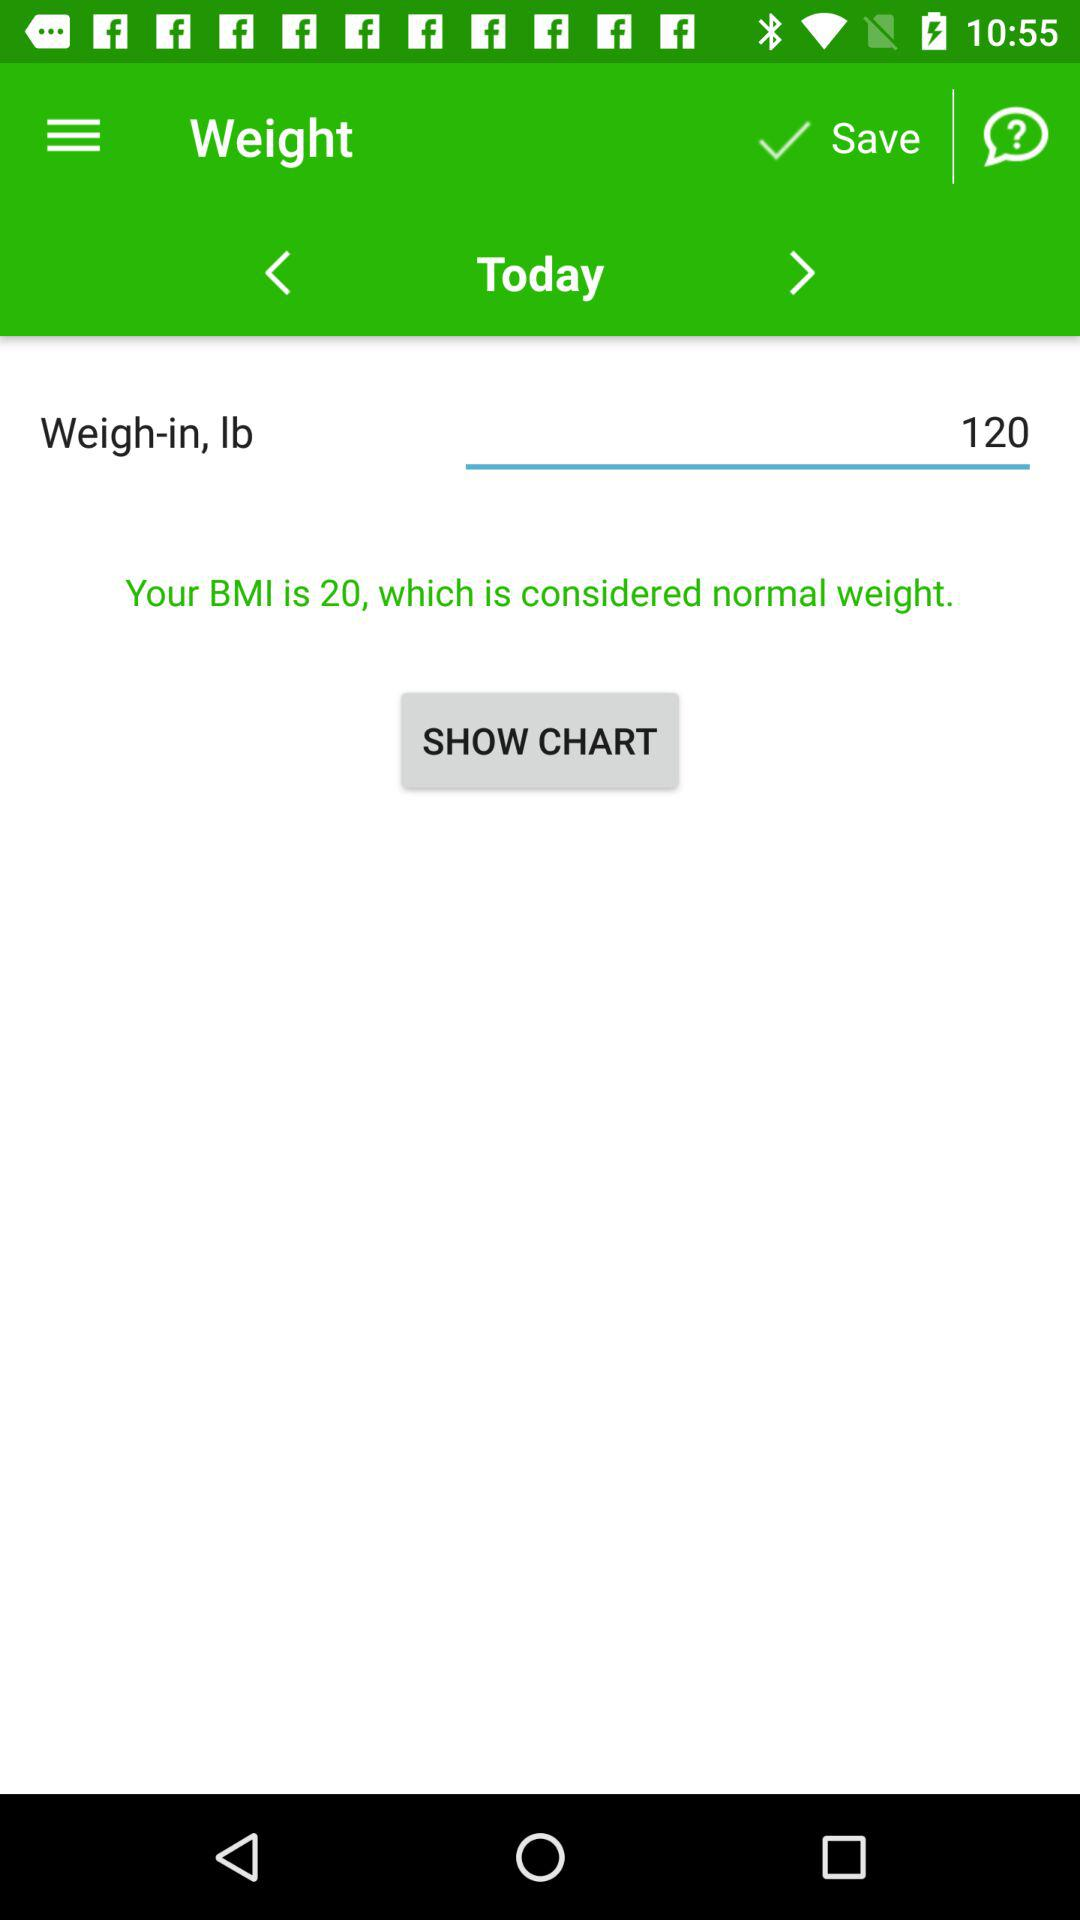What is the selected day? The selected day is today. 